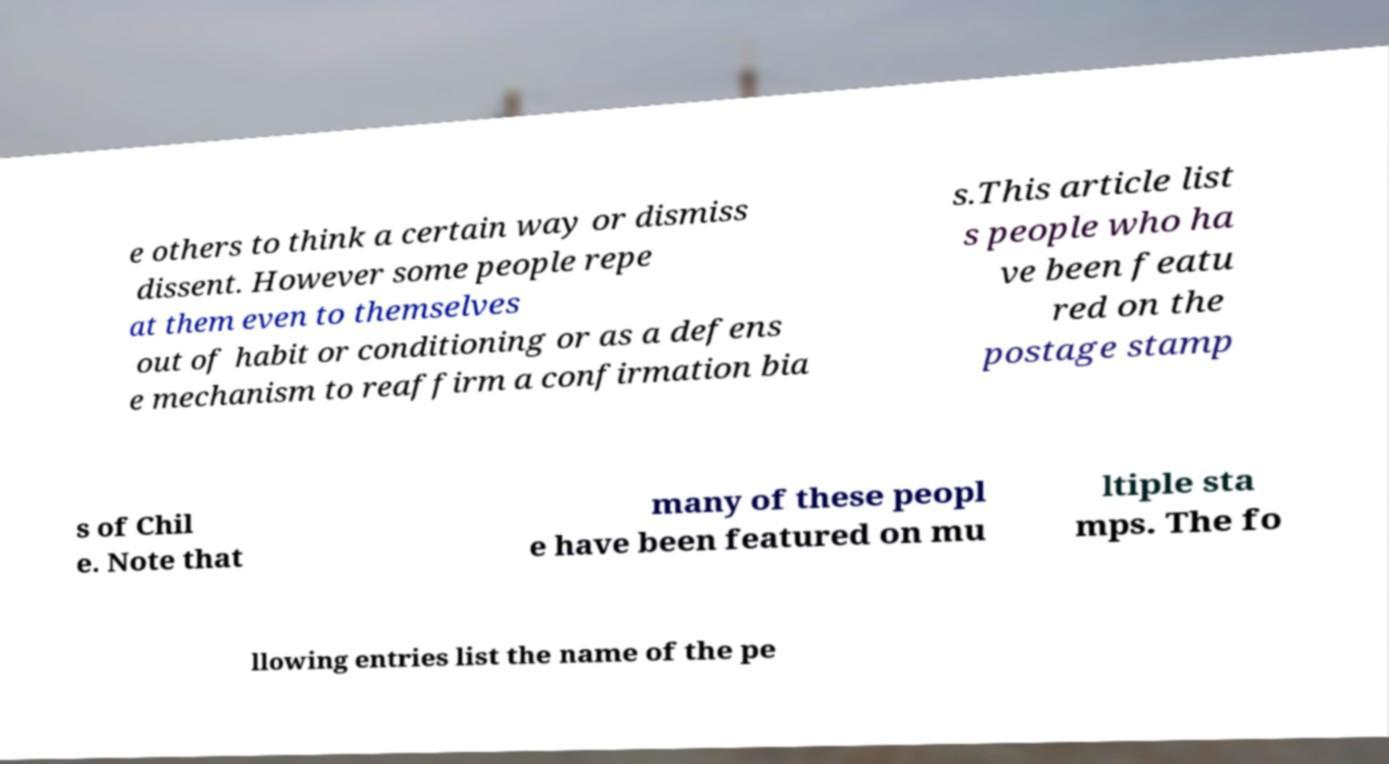Could you extract and type out the text from this image? e others to think a certain way or dismiss dissent. However some people repe at them even to themselves out of habit or conditioning or as a defens e mechanism to reaffirm a confirmation bia s.This article list s people who ha ve been featu red on the postage stamp s of Chil e. Note that many of these peopl e have been featured on mu ltiple sta mps. The fo llowing entries list the name of the pe 